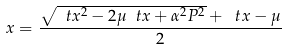<formula> <loc_0><loc_0><loc_500><loc_500>x = \frac { \sqrt { \ t x ^ { 2 } - 2 \mu \ t x + \alpha ^ { 2 } P ^ { 2 } } + \ t x - \mu } { 2 }</formula> 